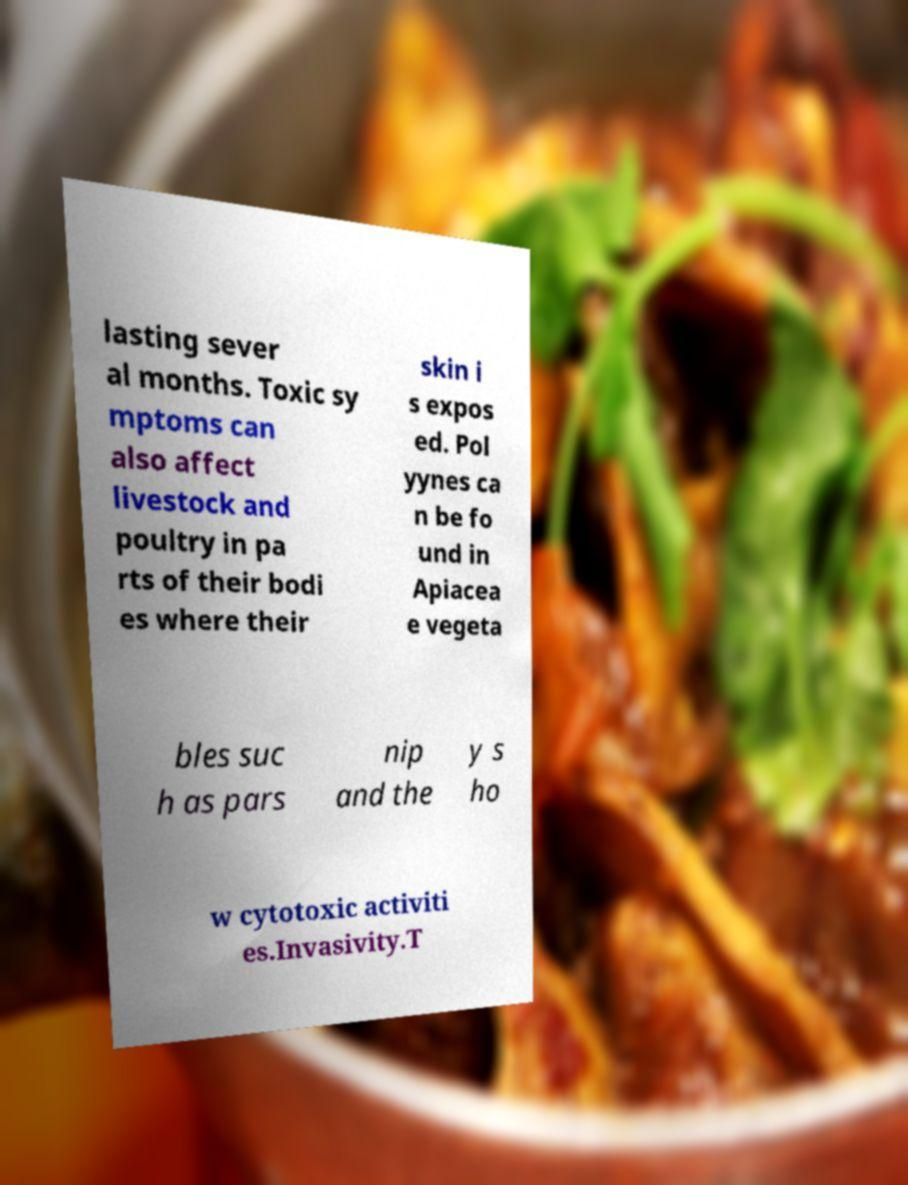Can you accurately transcribe the text from the provided image for me? lasting sever al months. Toxic sy mptoms can also affect livestock and poultry in pa rts of their bodi es where their skin i s expos ed. Pol yynes ca n be fo und in Apiacea e vegeta bles suc h as pars nip and the y s ho w cytotoxic activiti es.Invasivity.T 